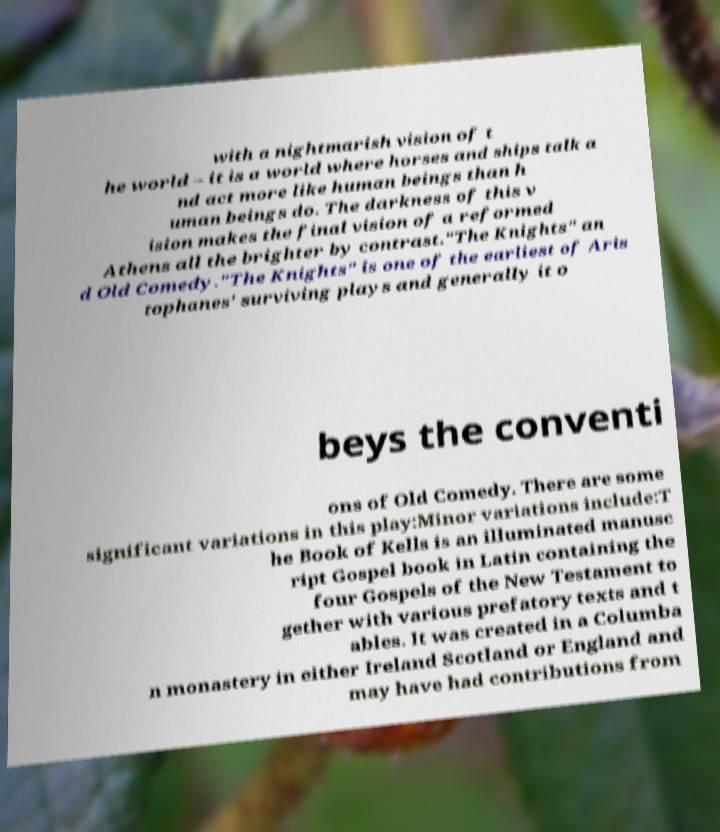Could you extract and type out the text from this image? with a nightmarish vision of t he world – it is a world where horses and ships talk a nd act more like human beings than h uman beings do. The darkness of this v ision makes the final vision of a reformed Athens all the brighter by contrast."The Knights" an d Old Comedy."The Knights" is one of the earliest of Aris tophanes' surviving plays and generally it o beys the conventi ons of Old Comedy. There are some significant variations in this play:Minor variations include:T he Book of Kells is an illuminated manusc ript Gospel book in Latin containing the four Gospels of the New Testament to gether with various prefatory texts and t ables. It was created in a Columba n monastery in either Ireland Scotland or England and may have had contributions from 